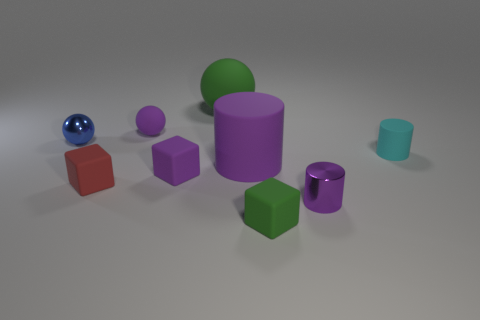The blue object that is the same shape as the big green matte thing is what size?
Your answer should be very brief. Small. Is the number of tiny matte things that are behind the tiny purple cylinder greater than the number of rubber balls?
Keep it short and to the point. Yes. Is the red block made of the same material as the green block?
Provide a short and direct response. Yes. How many objects are either big objects right of the big matte ball or balls on the left side of the green rubber sphere?
Make the answer very short. 3. What is the color of the other big thing that is the same shape as the blue metal object?
Your response must be concise. Green. What number of cubes are the same color as the big sphere?
Ensure brevity in your answer.  1. Is the color of the small metal cylinder the same as the metal sphere?
Your answer should be compact. No. How many things are either cubes that are in front of the purple rubber cube or tiny yellow rubber things?
Ensure brevity in your answer.  2. The rubber cylinder that is on the right side of the small cube that is in front of the small metallic thing in front of the blue metallic ball is what color?
Make the answer very short. Cyan. What color is the cylinder that is the same material as the blue ball?
Keep it short and to the point. Purple. 